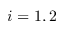Convert formula to latex. <formula><loc_0><loc_0><loc_500><loc_500>i = 1 , 2</formula> 